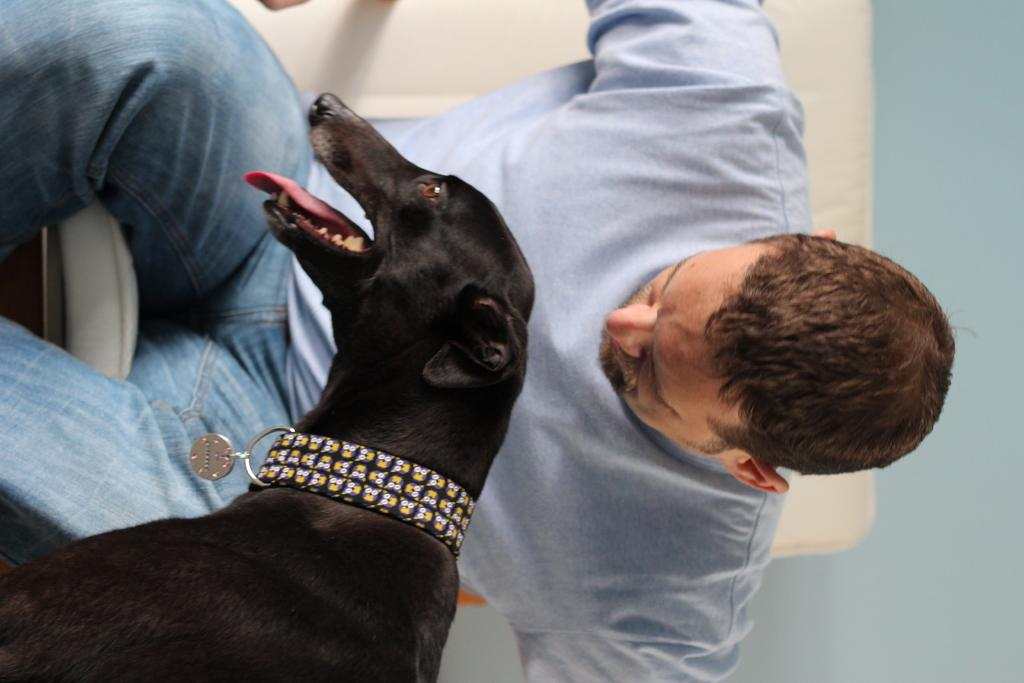What is the man in the image doing? The man is sitting in the image. What type of animal is present in the image? There is a black dog in the image. What type of plants can be seen growing in the field in the image? There is no field present in the image, so it is not possible to determine what type of plants might be growing there. 